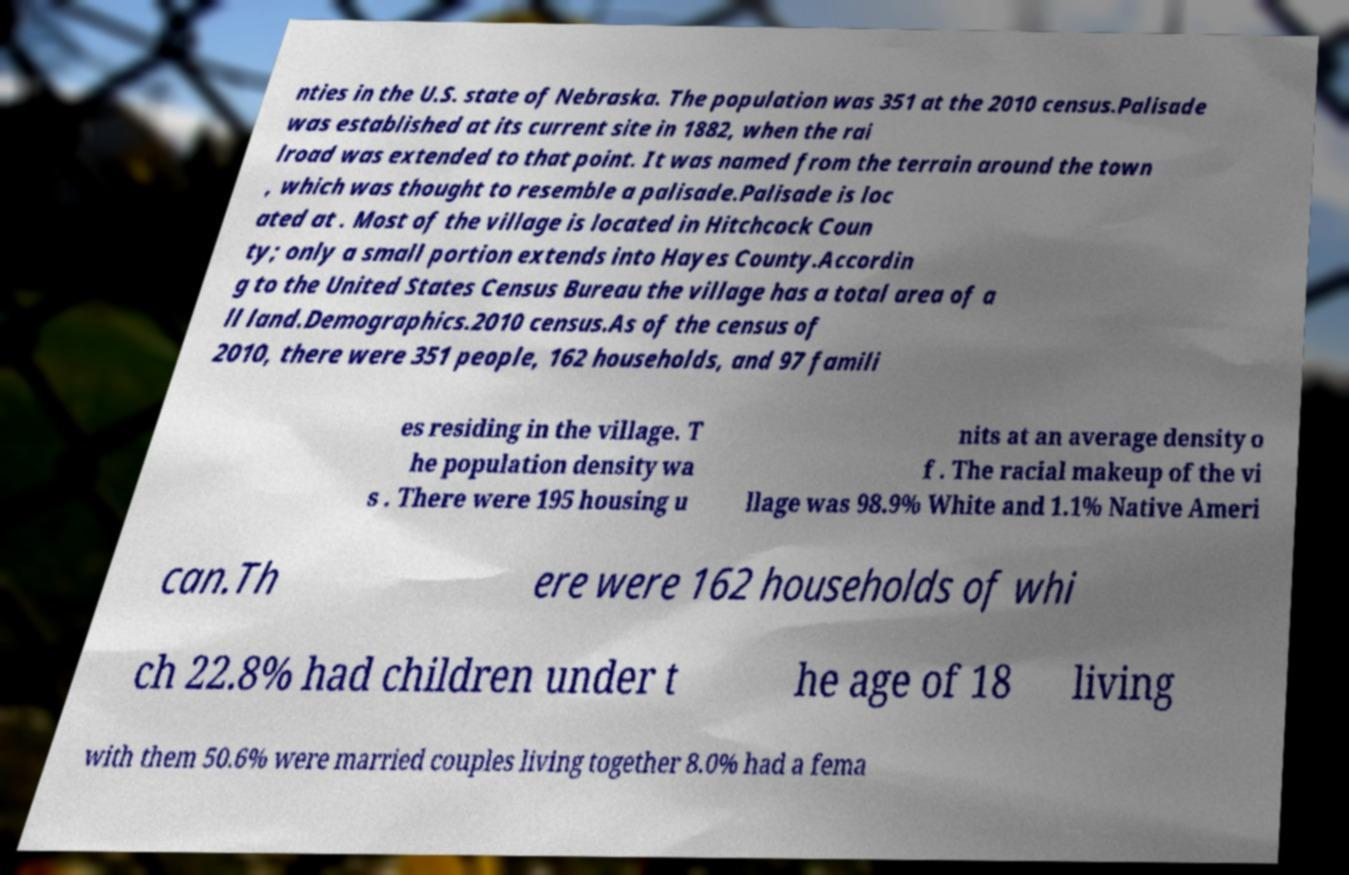Could you assist in decoding the text presented in this image and type it out clearly? nties in the U.S. state of Nebraska. The population was 351 at the 2010 census.Palisade was established at its current site in 1882, when the rai lroad was extended to that point. It was named from the terrain around the town , which was thought to resemble a palisade.Palisade is loc ated at . Most of the village is located in Hitchcock Coun ty; only a small portion extends into Hayes County.Accordin g to the United States Census Bureau the village has a total area of a ll land.Demographics.2010 census.As of the census of 2010, there were 351 people, 162 households, and 97 famili es residing in the village. T he population density wa s . There were 195 housing u nits at an average density o f . The racial makeup of the vi llage was 98.9% White and 1.1% Native Ameri can.Th ere were 162 households of whi ch 22.8% had children under t he age of 18 living with them 50.6% were married couples living together 8.0% had a fema 